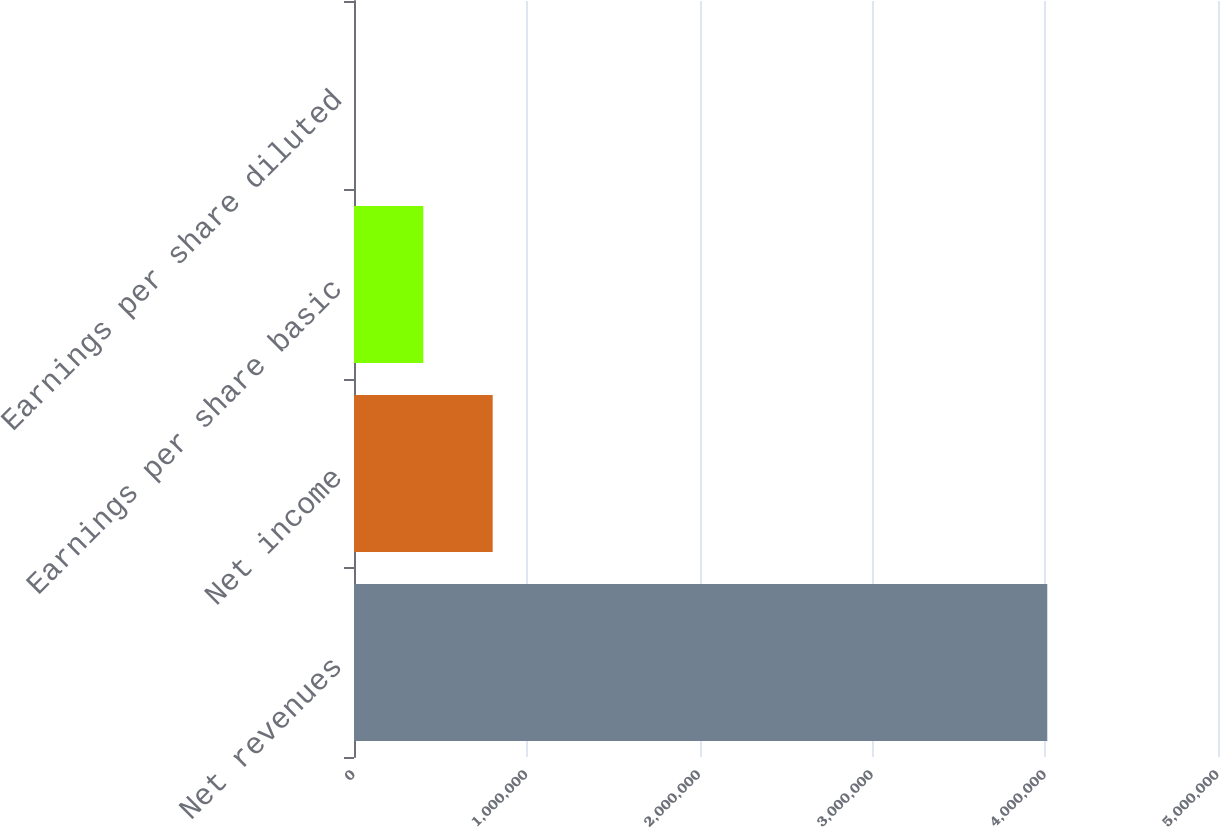<chart> <loc_0><loc_0><loc_500><loc_500><bar_chart><fcel>Net revenues<fcel>Net income<fcel>Earnings per share basic<fcel>Earnings per share diluted<nl><fcel>4.01203e+06<fcel>802411<fcel>401209<fcel>6.37<nl></chart> 